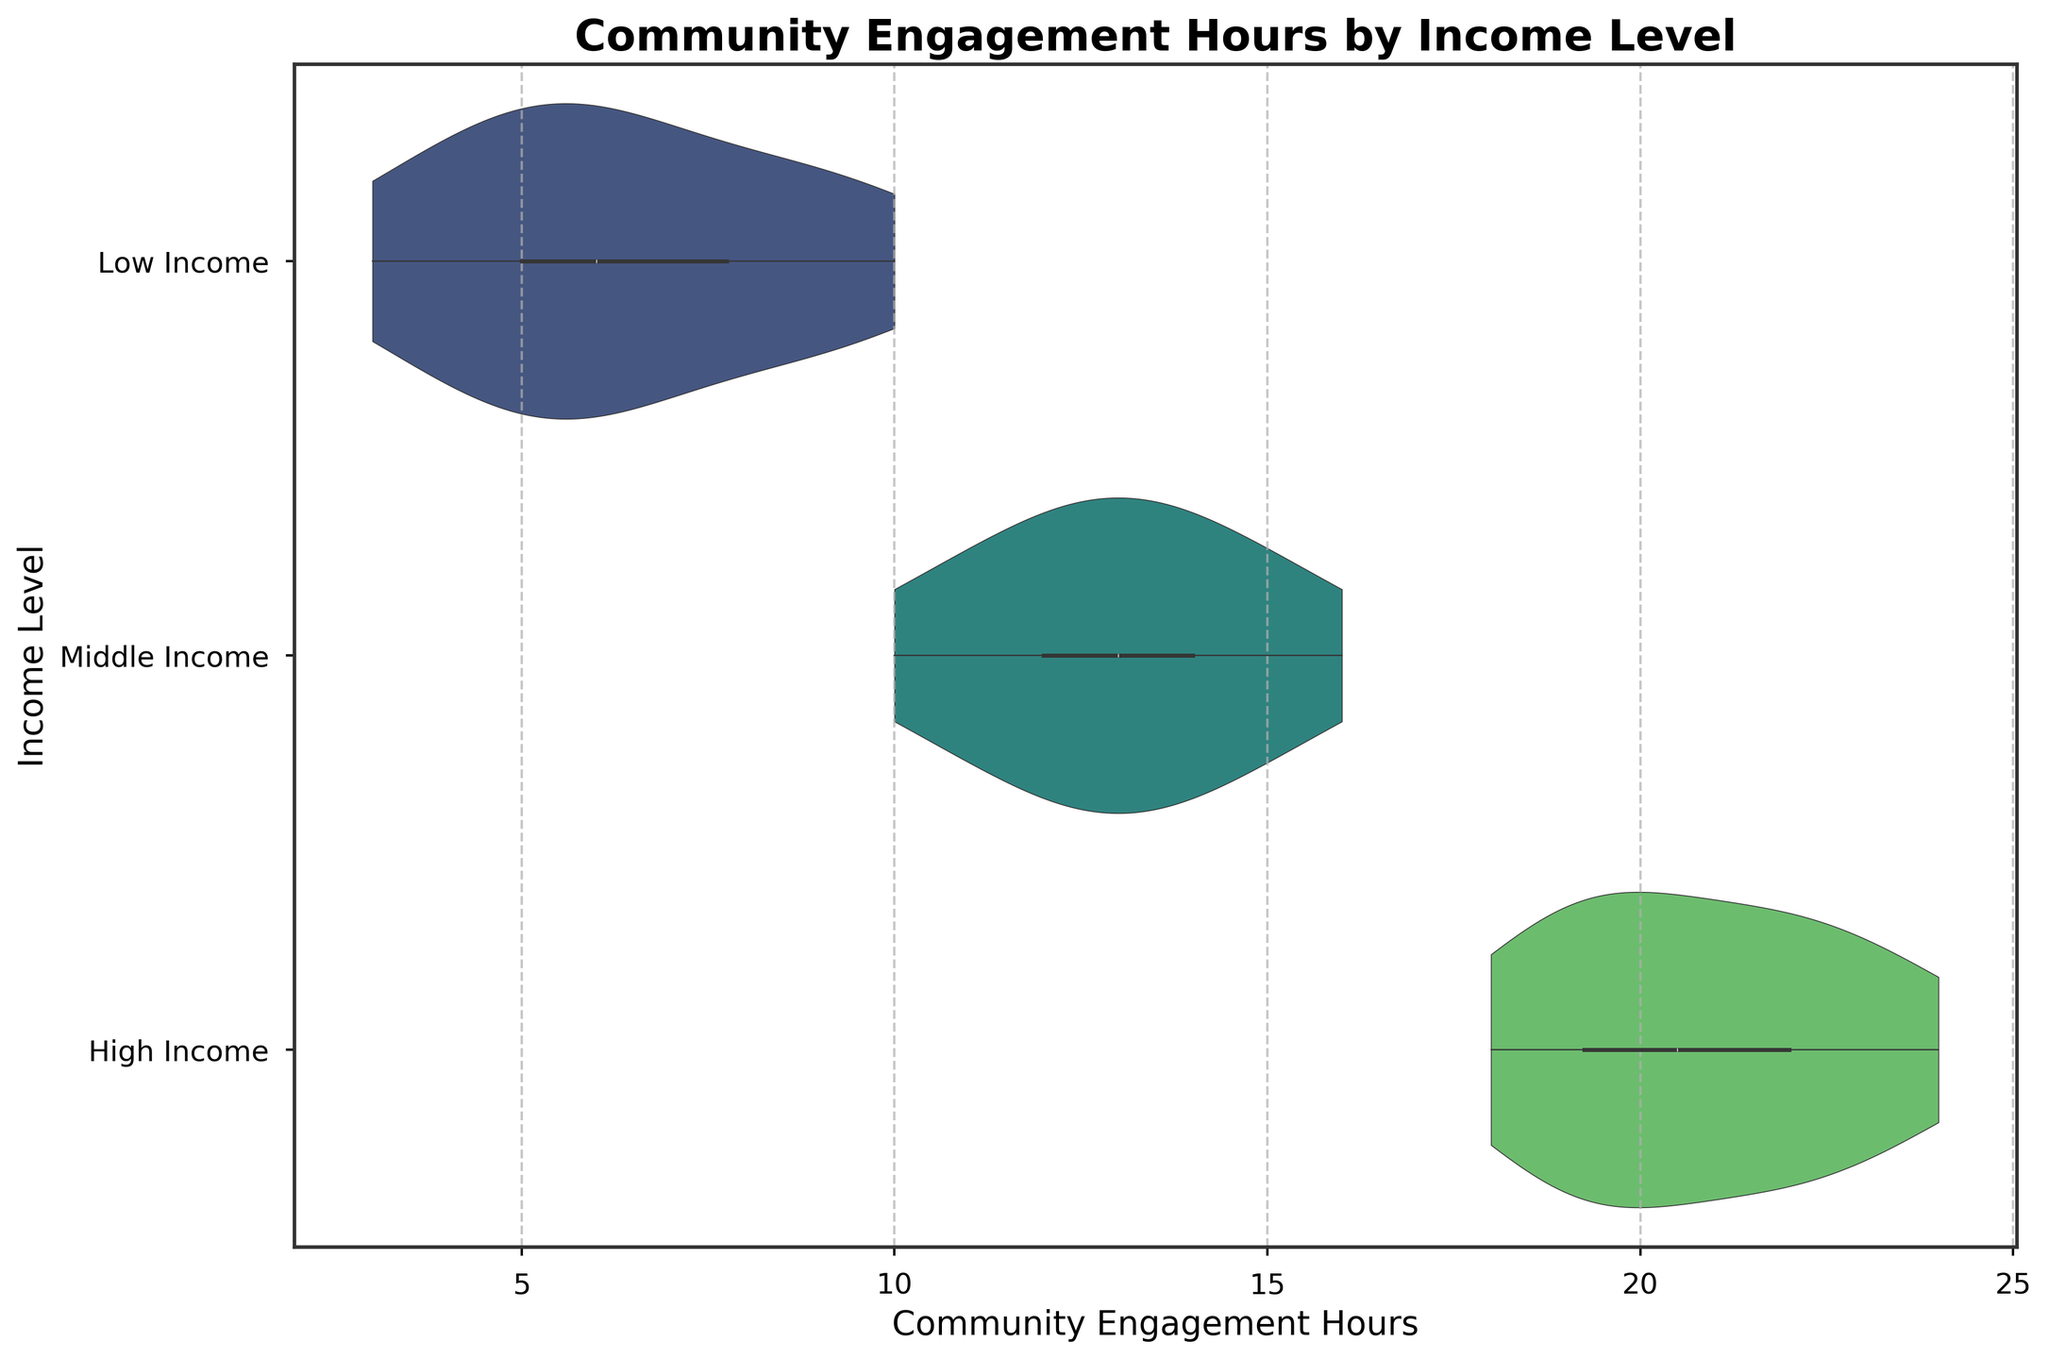What is the title of the figure? The title of the figure is prominently displayed at the top and reads "Community Engagement Hours by Income Level"
Answer: Community Engagement Hours by Income Level What is the x-axis label? The label for the x-axis can be seen below the horizontal axis in the figure, which is "Community Engagement Hours"
Answer: Community Engagement Hours Which income level has the highest range of community engagement hours? By examining the width and spread of the violin plots, we can see that the "High Income" group has the widest range, extending from 18 to 24 hours
Answer: High Income What is the median community engagement hour for the Low Income group? The violin plot includes a box plot inside it that indicates the median value, which appears around 6 hours for the Low Income group
Answer: 6 How does the distribution of community engagement hours differ between Low Income and High Income groups? The Low Income group shows a narrower and more centralized distribution around lower hours (approximately 3-10), while the High Income group has a wider range (18-24) and higher central tendency, indicating more variability and higher engagement
Answer: High Income has a wider range and higher central tendency What is the most densely populated community engagement hour range for Middle Income? The violin plot's width indicates density—the Middle Income group has the thickest part of the plot around 12 to 14 hours, suggesting the most engagement occurs in this range
Answer: 12 to 14 hours How does the average community engagement hours for Middle Income compare to Low Income? From the position of the central box plot and overall spread in the violin plots, Middle Income group hovers around higher engagement hours (about 12-14) compared to Low Income (around 5-7)
Answer: Middle Income has higher average engagement What can we infer about the variability in community engagement hours within the Low Income group? The Low Income group has a relatively narrow distribution in the violin plot, indicating low variability and most engagement hours clustering between 4 and 9 hours
Answer: Low variability Is there any overlap in community engagement hours between Middle Income and High Income groups? Observing the horizontal range of the violin plots, there's an overlap primarily in the range of 19-21 hours, implying some shared engagement levels between these income groups
Answer: Yes, in the 19-21 hours range 